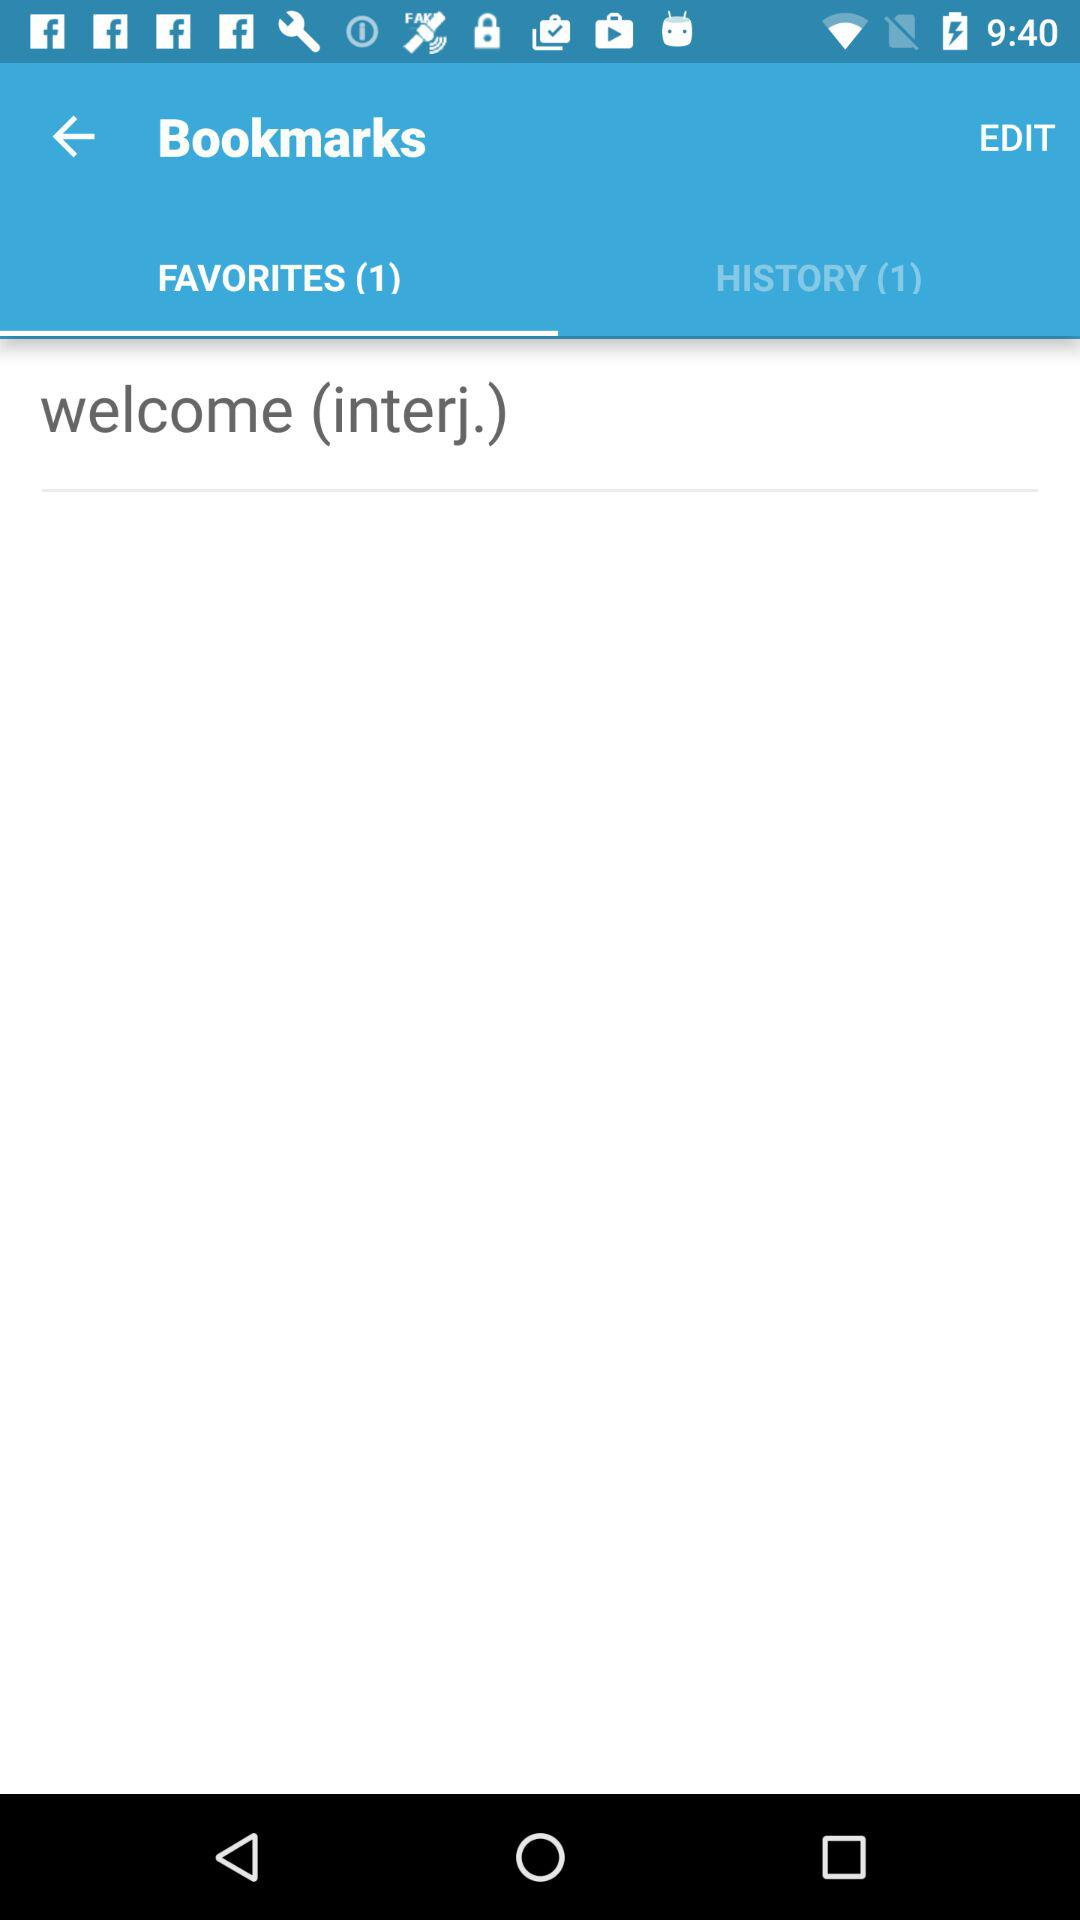Which option is selected in "Bookmarks"? The selected option is "FAVORITES". 